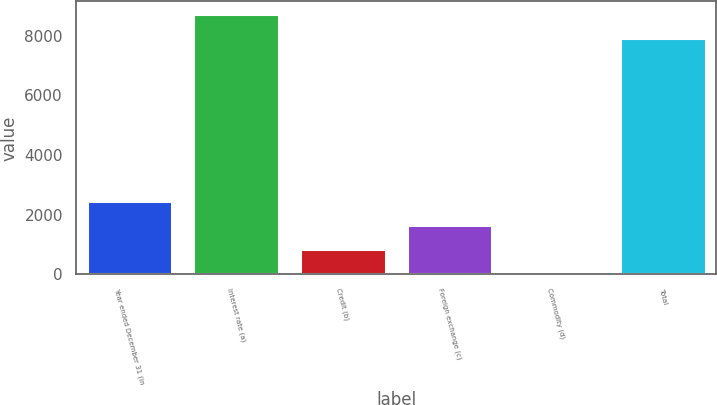Convert chart. <chart><loc_0><loc_0><loc_500><loc_500><bar_chart><fcel>Year ended December 31 (in<fcel>Interest rate (a)<fcel>Credit (b)<fcel>Foreign exchange (c)<fcel>Commodity (d)<fcel>Total<nl><fcel>2453.9<fcel>8720.3<fcel>845.3<fcel>1649.6<fcel>41<fcel>7916<nl></chart> 